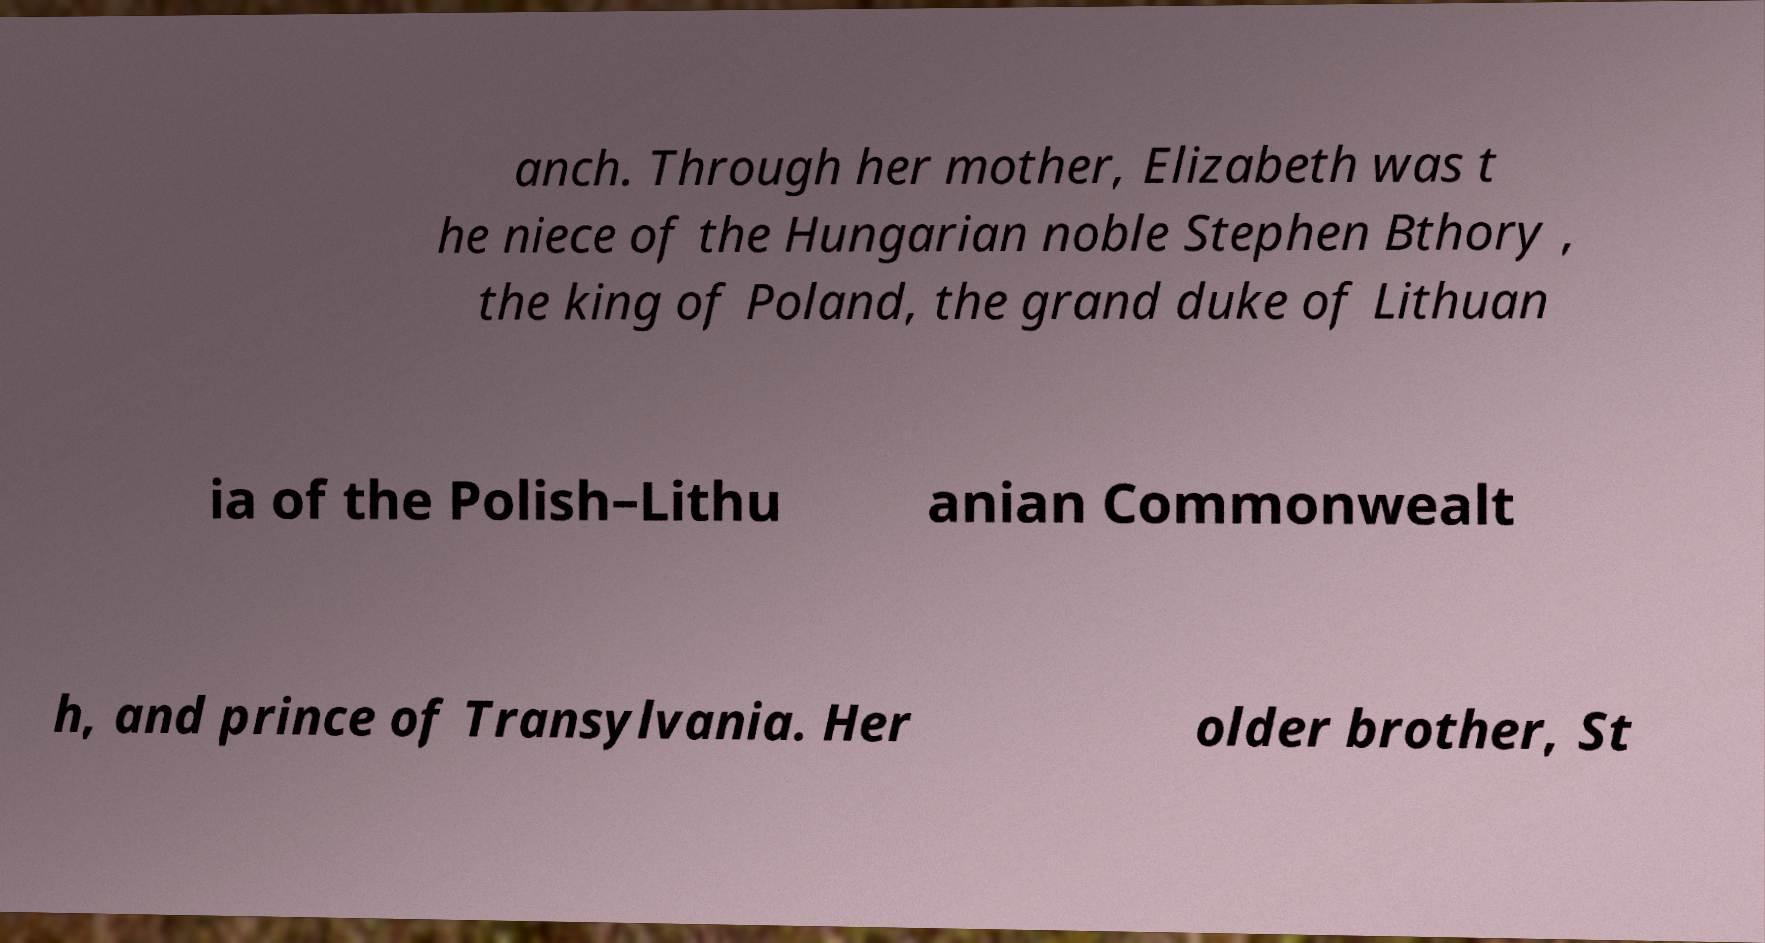Could you extract and type out the text from this image? anch. Through her mother, Elizabeth was t he niece of the Hungarian noble Stephen Bthory , the king of Poland, the grand duke of Lithuan ia of the Polish–Lithu anian Commonwealt h, and prince of Transylvania. Her older brother, St 